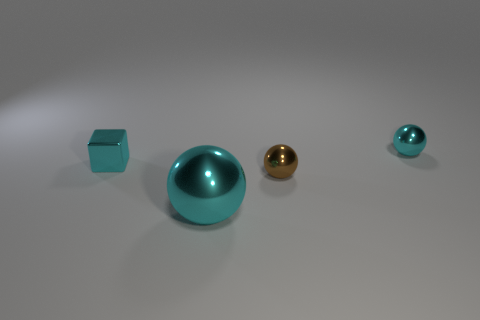What shape is the thing that is both to the left of the brown object and in front of the small cyan metal block?
Provide a short and direct response. Sphere. How many small cyan things are the same shape as the small brown thing?
Offer a terse response. 1. How many brown metallic balls are there?
Your answer should be very brief. 1. What is the size of the metal object that is left of the brown ball and behind the big metallic thing?
Provide a short and direct response. Small. What is the shape of the brown object that is the same size as the cyan cube?
Ensure brevity in your answer.  Sphere. There is a tiny cyan thing that is in front of the small cyan sphere; is there a tiny cyan shiny block in front of it?
Keep it short and to the point. No. Does the big ball on the left side of the tiny brown shiny ball have the same color as the tiny block?
Your response must be concise. Yes. What number of objects are big objects that are in front of the small cyan shiny sphere or small metal spheres?
Your answer should be compact. 3. There is a small cyan block that is to the left of the sphere that is on the left side of the small brown object that is in front of the tiny cyan metallic block; what is it made of?
Offer a very short reply. Metal. Is the number of large cyan shiny balls that are in front of the big sphere greater than the number of cyan metal spheres in front of the small cube?
Provide a succinct answer. No. 